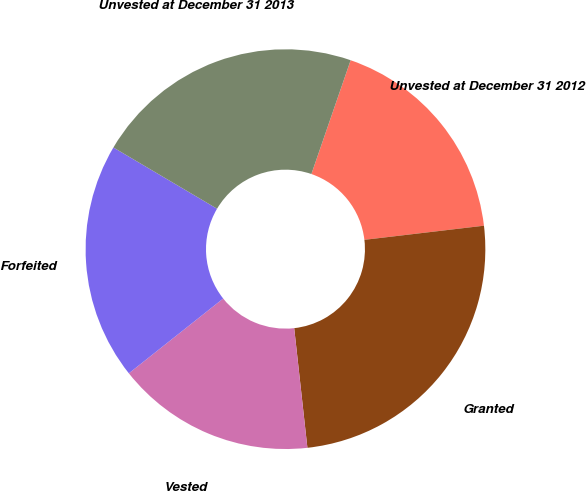Convert chart. <chart><loc_0><loc_0><loc_500><loc_500><pie_chart><fcel>Unvested at December 31 2012<fcel>Granted<fcel>Vested<fcel>Forfeited<fcel>Unvested at December 31 2013<nl><fcel>17.84%<fcel>25.12%<fcel>16.08%<fcel>19.16%<fcel>21.79%<nl></chart> 